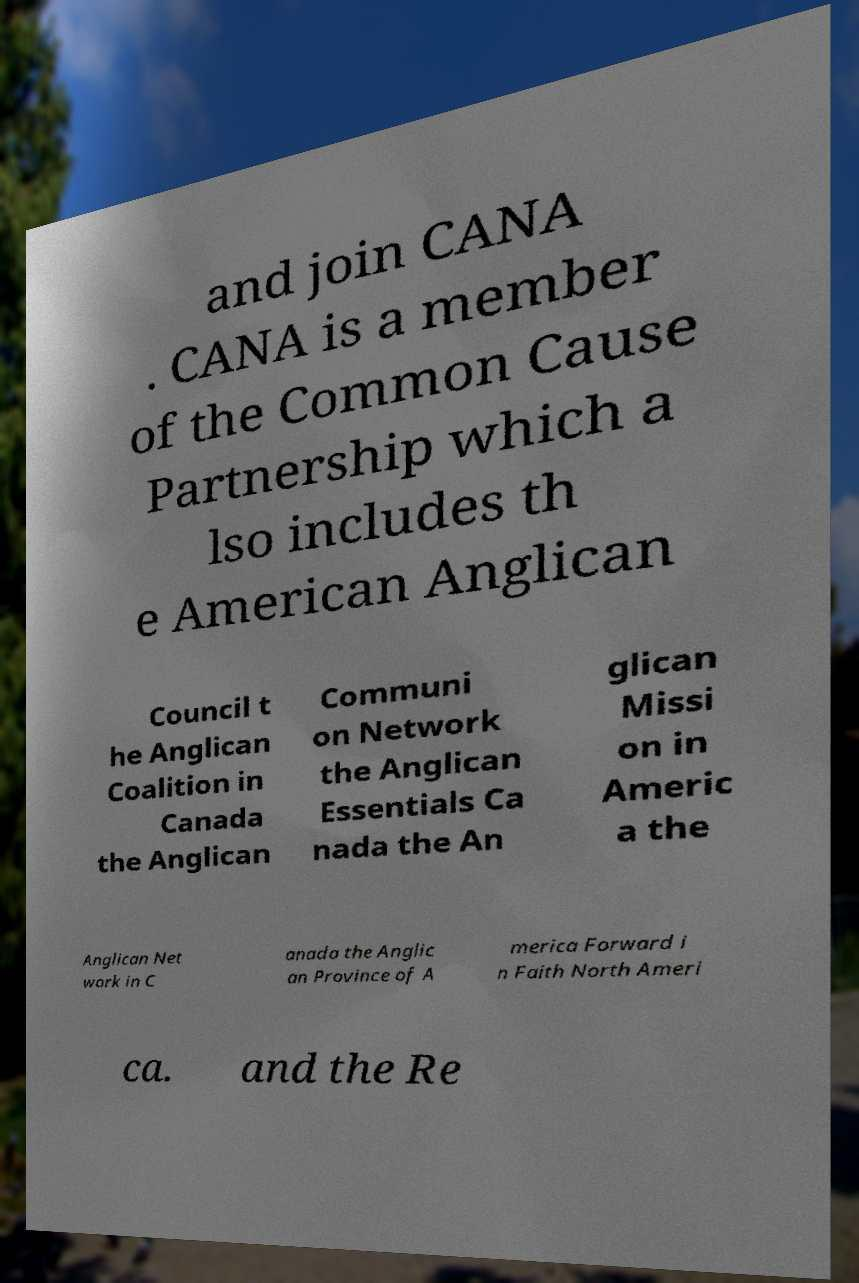Can you accurately transcribe the text from the provided image for me? and join CANA . CANA is a member of the Common Cause Partnership which a lso includes th e American Anglican Council t he Anglican Coalition in Canada the Anglican Communi on Network the Anglican Essentials Ca nada the An glican Missi on in Americ a the Anglican Net work in C anada the Anglic an Province of A merica Forward i n Faith North Ameri ca. and the Re 